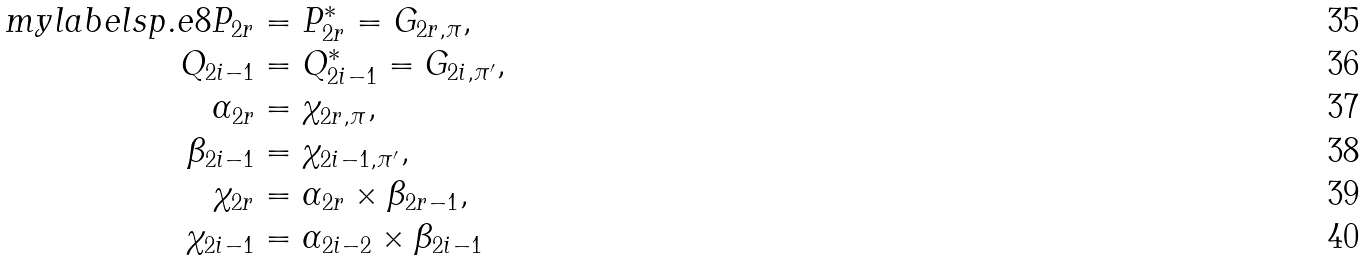<formula> <loc_0><loc_0><loc_500><loc_500>\ m y l a b e l { s p . e 8 } P _ { 2 r } & = P _ { 2 r } ^ { * } = G _ { 2 r , \pi } , \\ Q _ { 2 i - 1 } & = Q _ { 2 i - 1 } ^ { * } = G _ { 2 i , \pi ^ { \prime } } , \\ \alpha _ { 2 r } & = \chi _ { 2 r , \pi } , \\ \beta _ { 2 i - 1 } & = \chi _ { 2 i - 1 , \pi ^ { \prime } } , \\ \chi _ { 2 r } & = \alpha _ { 2 r } \times \beta _ { 2 r - 1 } , \\ \chi _ { 2 i - 1 } & = \alpha _ { 2 i - 2 } \times \beta _ { 2 i - 1 }</formula> 